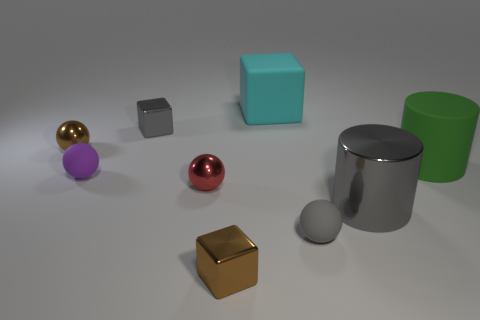Subtract all tiny metal blocks. How many blocks are left? 1 Add 1 cyan blocks. How many objects exist? 10 Subtract all cyan cubes. How many cubes are left? 2 Subtract 2 cylinders. How many cylinders are left? 0 Add 7 small brown balls. How many small brown balls are left? 8 Add 1 tiny rubber objects. How many tiny rubber objects exist? 3 Subtract 1 gray balls. How many objects are left? 8 Subtract all balls. How many objects are left? 5 Subtract all blue spheres. Subtract all gray cylinders. How many spheres are left? 4 Subtract all cyan spheres. How many cyan cubes are left? 1 